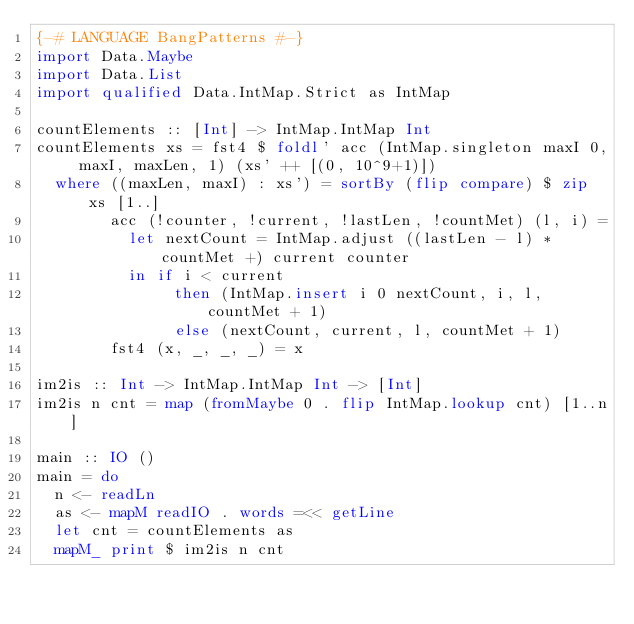<code> <loc_0><loc_0><loc_500><loc_500><_Haskell_>{-# LANGUAGE BangPatterns #-}
import Data.Maybe
import Data.List
import qualified Data.IntMap.Strict as IntMap

countElements :: [Int] -> IntMap.IntMap Int
countElements xs = fst4 $ foldl' acc (IntMap.singleton maxI 0, maxI, maxLen, 1) (xs' ++ [(0, 10^9+1)])
  where ((maxLen, maxI) : xs') = sortBy (flip compare) $ zip xs [1..]
        acc (!counter, !current, !lastLen, !countMet) (l, i) =
          let nextCount = IntMap.adjust ((lastLen - l) * countMet +) current counter
          in if i < current
               then (IntMap.insert i 0 nextCount, i, l, countMet + 1)
               else (nextCount, current, l, countMet + 1)
        fst4 (x, _, _, _) = x

im2is :: Int -> IntMap.IntMap Int -> [Int]
im2is n cnt = map (fromMaybe 0 . flip IntMap.lookup cnt) [1..n]

main :: IO ()
main = do
  n <- readLn
  as <- mapM readIO . words =<< getLine
  let cnt = countElements as
  mapM_ print $ im2is n cnt
</code> 